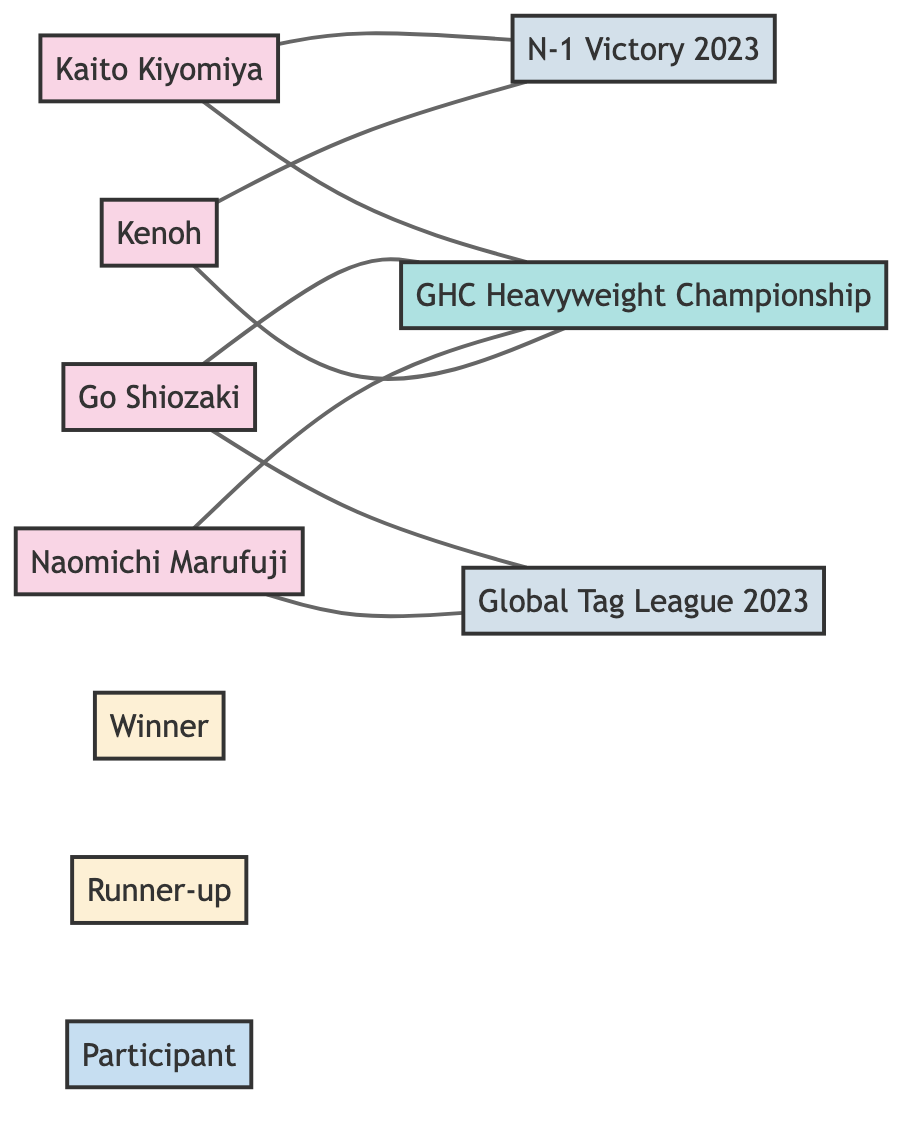What tournaments did Kaito Kiyomiya participate in? Kaito Kiyomiya is connected to the "N-1 Victory 2023" and the "GHC Heavyweight Championship" in the diagram, indicating his participation in both tournaments.
Answer: N-1 Victory 2023, GHC Heavyweight Championship Who won the Global Tag League 2023? The diagram indicates that Naomichi Marufuji is connected to the "Global Tag League 2023" with the relation "Winner", indicating he won the tournament.
Answer: Naomichi Marufuji How many wrestlers are represented in the diagram? By counting the unique wrestler nodes listed in the diagram, there are four wrestlers: Kaito Kiyomiya, Go Shiozaki, Naomichi Marufuji, and Kenoh.
Answer: 4 What is the relationship between Go Shiozaki and GHC Heavyweight Championship? The diagram shows an edge between Go Shiozaki and the "GHC Heavyweight Championship" with the relation "Winner", meaning he won this title.
Answer: Winner Which tournament did Kenoh win? The diagram shows an edge between Kenoh and "N-1 Victory 2023" with the relation "Winner", indicating he is the winner of this tournament.
Answer: N-1 Victory 2023 Which title did Kaito Kiyomiya finish as runner-up? The diagram shows an edge between Kaito Kiyomiya and "GHC Heavyweight Championship" with the relation "Runner-up", indicating he was the runner-up for this title.
Answer: GHC Heavyweight Championship How many outcomes (Winner, Runner-up, Participant) are identified in the diagram? The diagram has three outcome nodes: "Winner", "Runner-up", and "Participant", indicating a total of three outcomes related to the tournaments.
Answer: 3 Which wrestler was a participant in both major tournaments? The diagram shows that Kaito Kiyomiya participated in "N-1 Victory 2023" and the "GHC Heavyweight Championship", and Kenoh also participated in "N-1 Victory 2023" and the "GHC Heavyweight Championship", but since the question is for one wrestler, Kaito Kiyomiya is one of the wrestlers participating in both tournaments.
Answer: Kaito Kiyomiya How many edges are connected to the GHC Heavyweight Championship? The diagram has three edges connecting to the "GHC Heavyweight Championship"; one from each of the listed participants: Kaito Kiyomiya, Go Shiozaki, and Kenoh, and one where Kaito Kiyomiya is the runner-up.
Answer: 4 